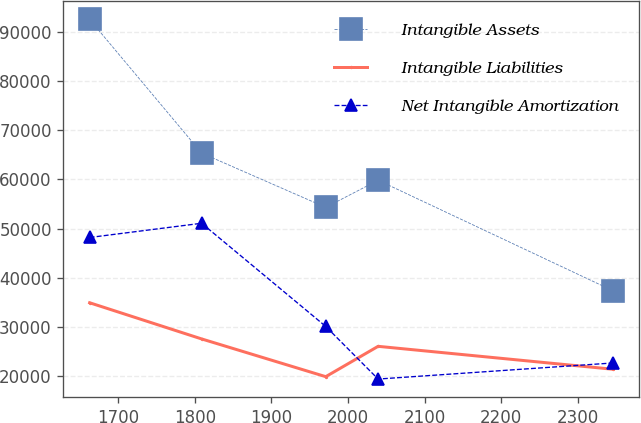<chart> <loc_0><loc_0><loc_500><loc_500><line_chart><ecel><fcel>Intangible Assets<fcel>Intangible Liabilities<fcel>Net Intangible Amortization<nl><fcel>1662.38<fcel>92564.9<fcel>34891.8<fcel>48180.2<nl><fcel>1808.72<fcel>65360.2<fcel>27526.3<fcel>51076.4<nl><fcel>1970.89<fcel>54309.1<fcel>19844.6<fcel>30072.2<nl><fcel>2039.31<fcel>59834.6<fcel>26021.6<fcel>19358.7<nl><fcel>2346.57<fcel>37309.4<fcel>21349.4<fcel>22638.4<nl></chart> 